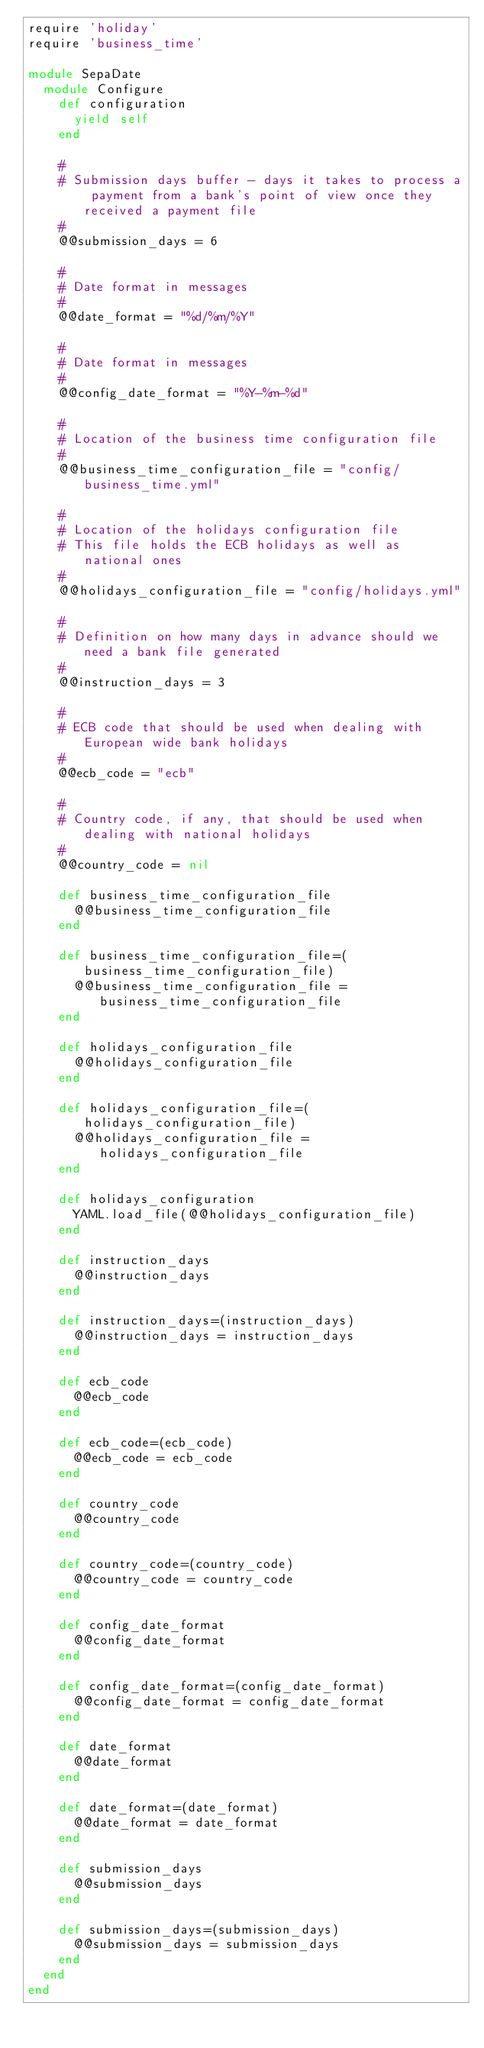Convert code to text. <code><loc_0><loc_0><loc_500><loc_500><_Ruby_>require 'holiday'
require 'business_time'

module SepaDate
  module Configure
    def configuration
      yield self
    end

    #
    # Submission days buffer - days it takes to process a payment from a bank's point of view once they received a payment file
    #
    @@submission_days = 6

    #
    # Date format in messages
    #
    @@date_format = "%d/%m/%Y"

    #
    # Date format in messages
    #
    @@config_date_format = "%Y-%m-%d"

    #
    # Location of the business time configuration file
    #
    @@business_time_configuration_file = "config/business_time.yml"

    #
    # Location of the holidays configuration file
    # This file holds the ECB holidays as well as national ones
    #
    @@holidays_configuration_file = "config/holidays.yml"

    #
    # Definition on how many days in advance should we need a bank file generated
    #
    @@instruction_days = 3

    #
    # ECB code that should be used when dealing with European wide bank holidays
    #
    @@ecb_code = "ecb"

    #
    # Country code, if any, that should be used when dealing with national holidays
    #
    @@country_code = nil

    def business_time_configuration_file
      @@business_time_configuration_file
    end

    def business_time_configuration_file=(business_time_configuration_file)
      @@business_time_configuration_file = business_time_configuration_file
    end

    def holidays_configuration_file
      @@holidays_configuration_file
    end

    def holidays_configuration_file=(holidays_configuration_file)
      @@holidays_configuration_file = holidays_configuration_file
    end

    def holidays_configuration
      YAML.load_file(@@holidays_configuration_file)
    end

    def instruction_days
      @@instruction_days
    end

    def instruction_days=(instruction_days)
      @@instruction_days = instruction_days
    end

    def ecb_code
      @@ecb_code
    end

    def ecb_code=(ecb_code)
      @@ecb_code = ecb_code
    end

    def country_code
      @@country_code
    end

    def country_code=(country_code)
      @@country_code = country_code
    end

    def config_date_format
      @@config_date_format
    end

    def config_date_format=(config_date_format)
      @@config_date_format = config_date_format
    end

    def date_format
      @@date_format
    end

    def date_format=(date_format)
      @@date_format = date_format
    end

    def submission_days
      @@submission_days
    end

    def submission_days=(submission_days)
      @@submission_days = submission_days
    end
  end
end
</code> 